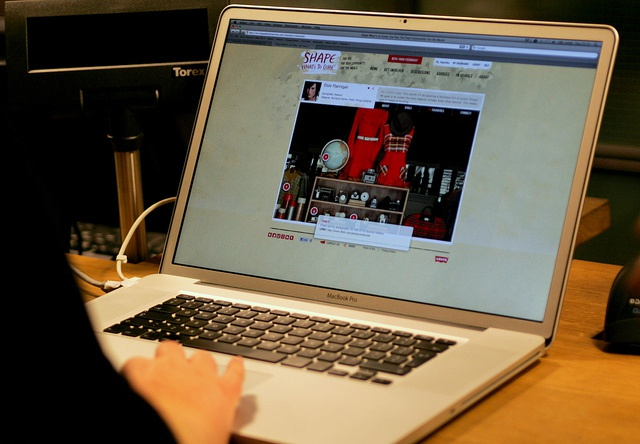Describe the objects in this image and their specific colors. I can see laptop in black, darkgray, gray, and tan tones and people in black, orange, and brown tones in this image. 